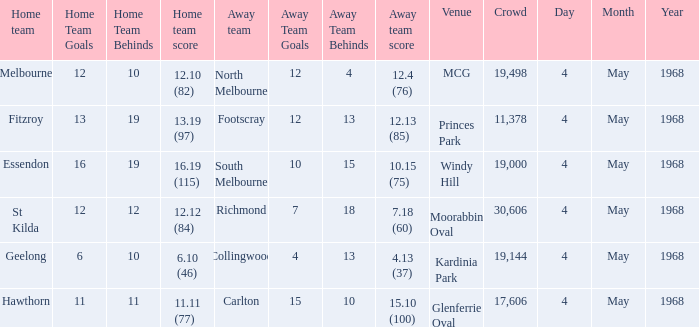How big was the crowd of the team that scored 4.13 (37)? 19144.0. 